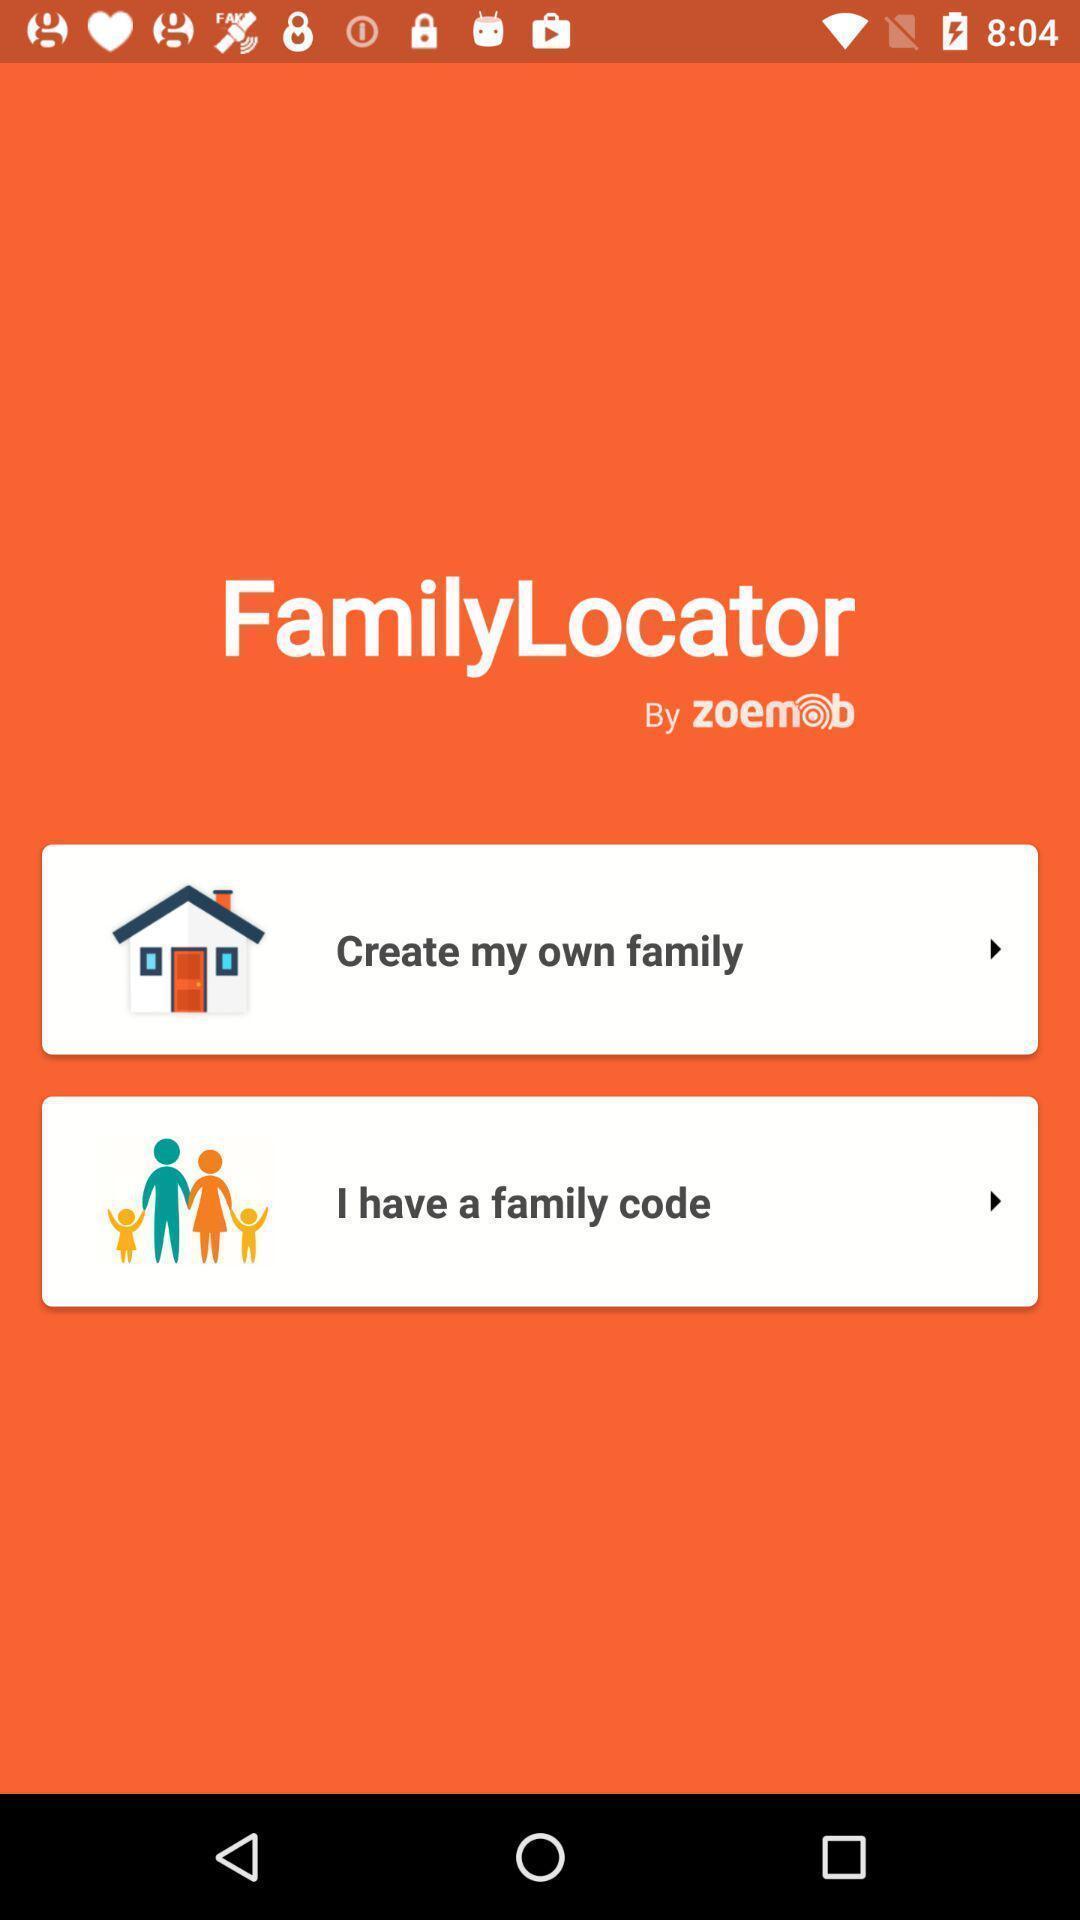What can you discern from this picture? Welcome page. 